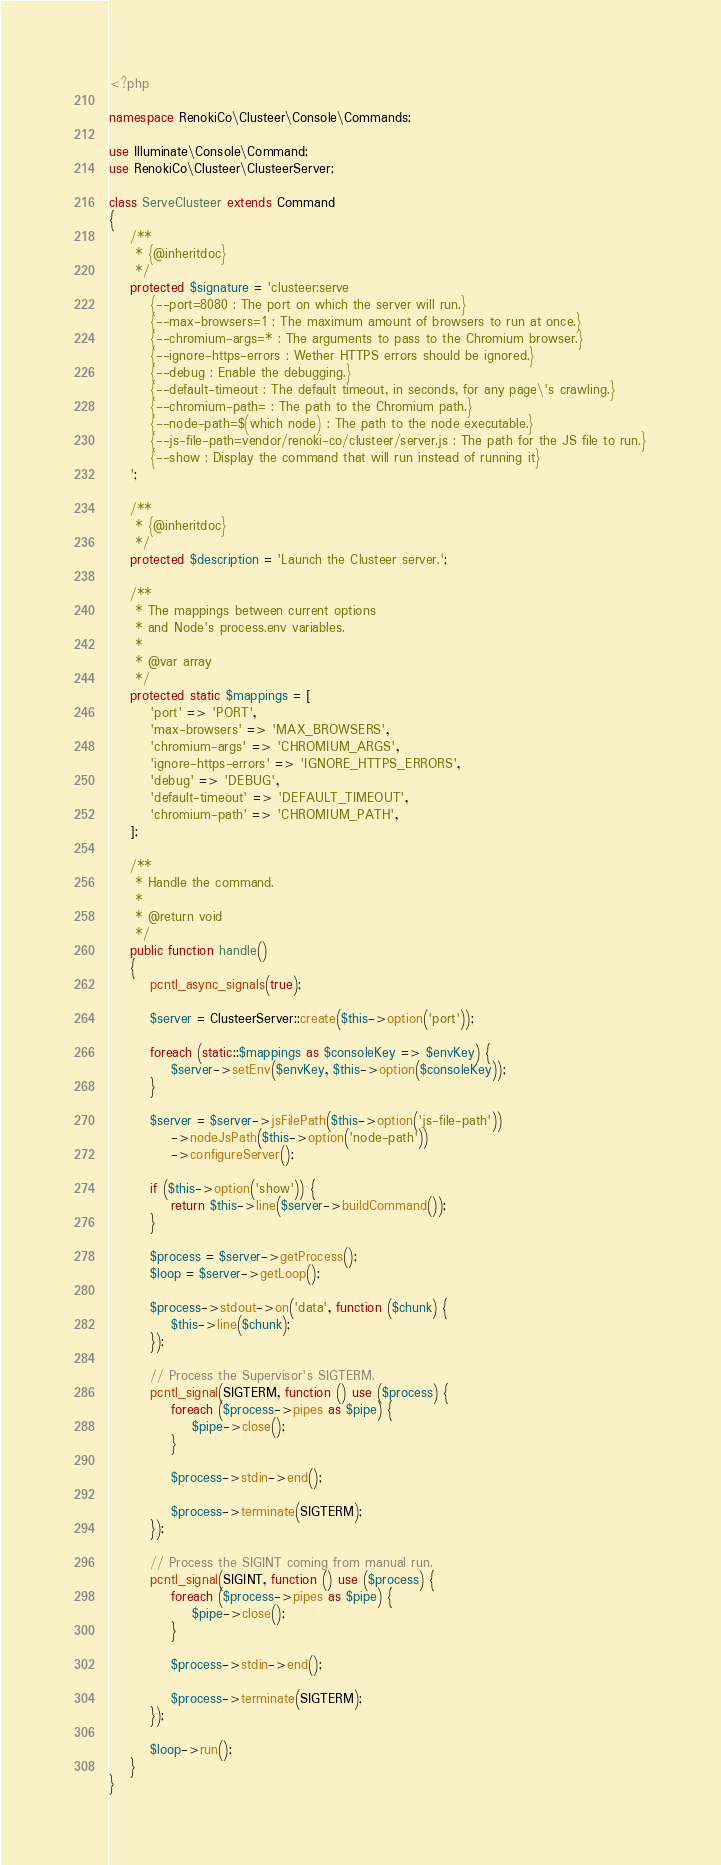Convert code to text. <code><loc_0><loc_0><loc_500><loc_500><_PHP_><?php

namespace RenokiCo\Clusteer\Console\Commands;

use Illuminate\Console\Command;
use RenokiCo\Clusteer\ClusteerServer;

class ServeClusteer extends Command
{
    /**
     * {@inheritdoc}
     */
    protected $signature = 'clusteer:serve
        {--port=8080 : The port on which the server will run.}
        {--max-browsers=1 : The maximum amount of browsers to run at once.}
        {--chromium-args=* : The arguments to pass to the Chromium browser.}
        {--ignore-https-errors : Wether HTTPS errors should be ignored.}
        {--debug : Enable the debugging.}
        {--default-timeout : The default timeout, in seconds, for any page\'s crawling.}
        {--chromium-path= : The path to the Chromium path.}
        {--node-path=$(which node) : The path to the node executable.}
        {--js-file-path=vendor/renoki-co/clusteer/server.js : The path for the JS file to run.}
        {--show : Display the command that will run instead of running it}
    ';

    /**
     * {@inheritdoc}
     */
    protected $description = 'Launch the Clusteer server.';

    /**
     * The mappings between current options
     * and Node's process.env variables.
     *
     * @var array
     */
    protected static $mappings = [
        'port' => 'PORT',
        'max-browsers' => 'MAX_BROWSERS',
        'chromium-args' => 'CHROMIUM_ARGS',
        'ignore-https-errors' => 'IGNORE_HTTPS_ERRORS',
        'debug' => 'DEBUG',
        'default-timeout' => 'DEFAULT_TIMEOUT',
        'chromium-path' => 'CHROMIUM_PATH',
    ];

    /**
     * Handle the command.
     *
     * @return void
     */
    public function handle()
    {
        pcntl_async_signals(true);

        $server = ClusteerServer::create($this->option('port'));

        foreach (static::$mappings as $consoleKey => $envKey) {
            $server->setEnv($envKey, $this->option($consoleKey));
        }

        $server = $server->jsFilePath($this->option('js-file-path'))
            ->nodeJsPath($this->option('node-path'))
            ->configureServer();

        if ($this->option('show')) {
            return $this->line($server->buildCommand());
        }

        $process = $server->getProcess();
        $loop = $server->getLoop();

        $process->stdout->on('data', function ($chunk) {
            $this->line($chunk);
        });

        // Process the Supervisor's SIGTERM.
        pcntl_signal(SIGTERM, function () use ($process) {
            foreach ($process->pipes as $pipe) {
                $pipe->close();
            }

            $process->stdin->end();

            $process->terminate(SIGTERM);
        });

        // Process the SIGINT coming from manual run.
        pcntl_signal(SIGINT, function () use ($process) {
            foreach ($process->pipes as $pipe) {
                $pipe->close();
            }

            $process->stdin->end();

            $process->terminate(SIGTERM);
        });

        $loop->run();
    }
}
</code> 